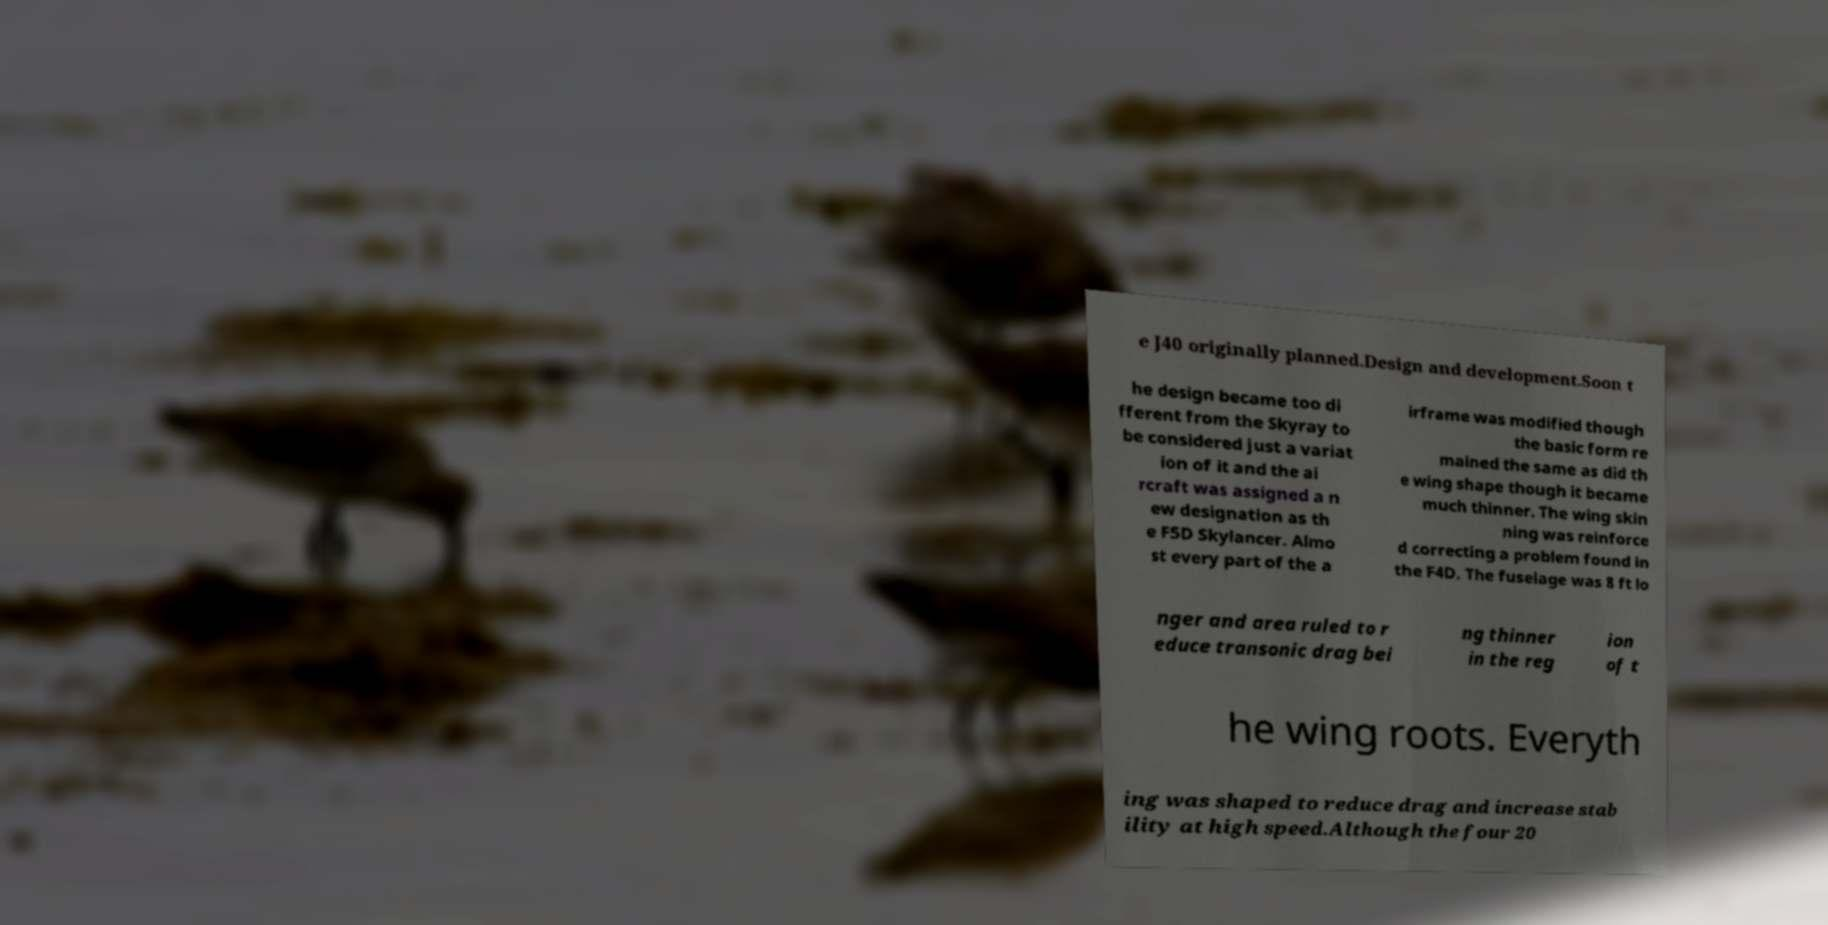Could you assist in decoding the text presented in this image and type it out clearly? e J40 originally planned.Design and development.Soon t he design became too di fferent from the Skyray to be considered just a variat ion of it and the ai rcraft was assigned a n ew designation as th e F5D Skylancer. Almo st every part of the a irframe was modified though the basic form re mained the same as did th e wing shape though it became much thinner. The wing skin ning was reinforce d correcting a problem found in the F4D. The fuselage was 8 ft lo nger and area ruled to r educe transonic drag bei ng thinner in the reg ion of t he wing roots. Everyth ing was shaped to reduce drag and increase stab ility at high speed.Although the four 20 